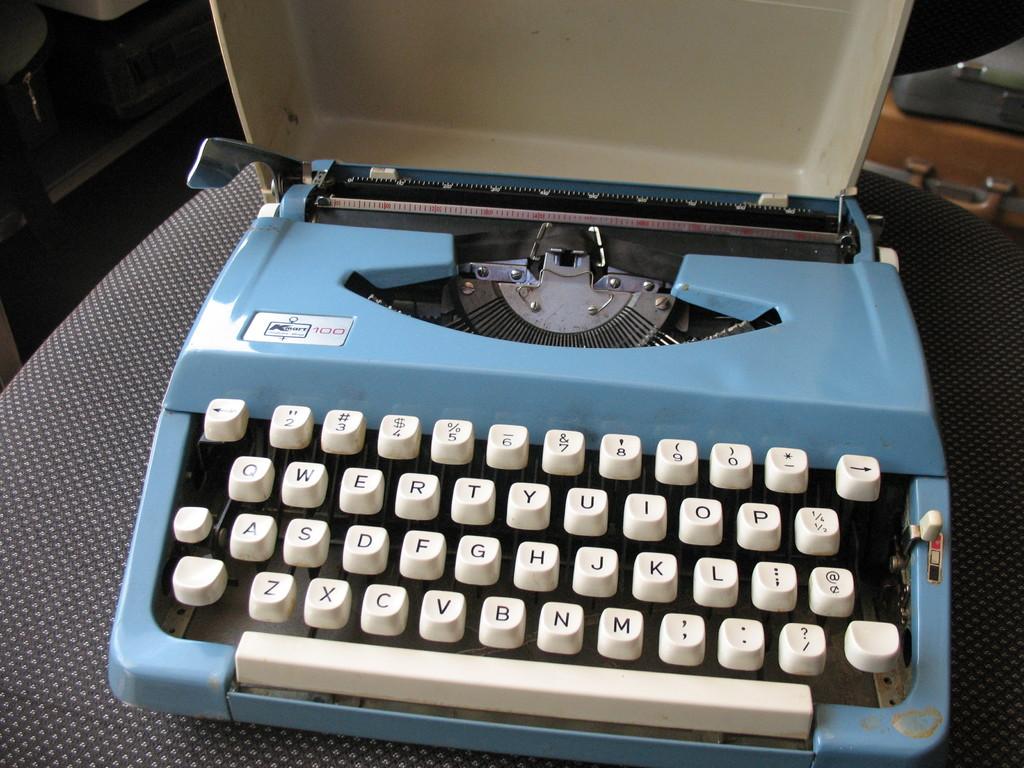Who is invent by the machine?
Offer a terse response. Unanswerable. 